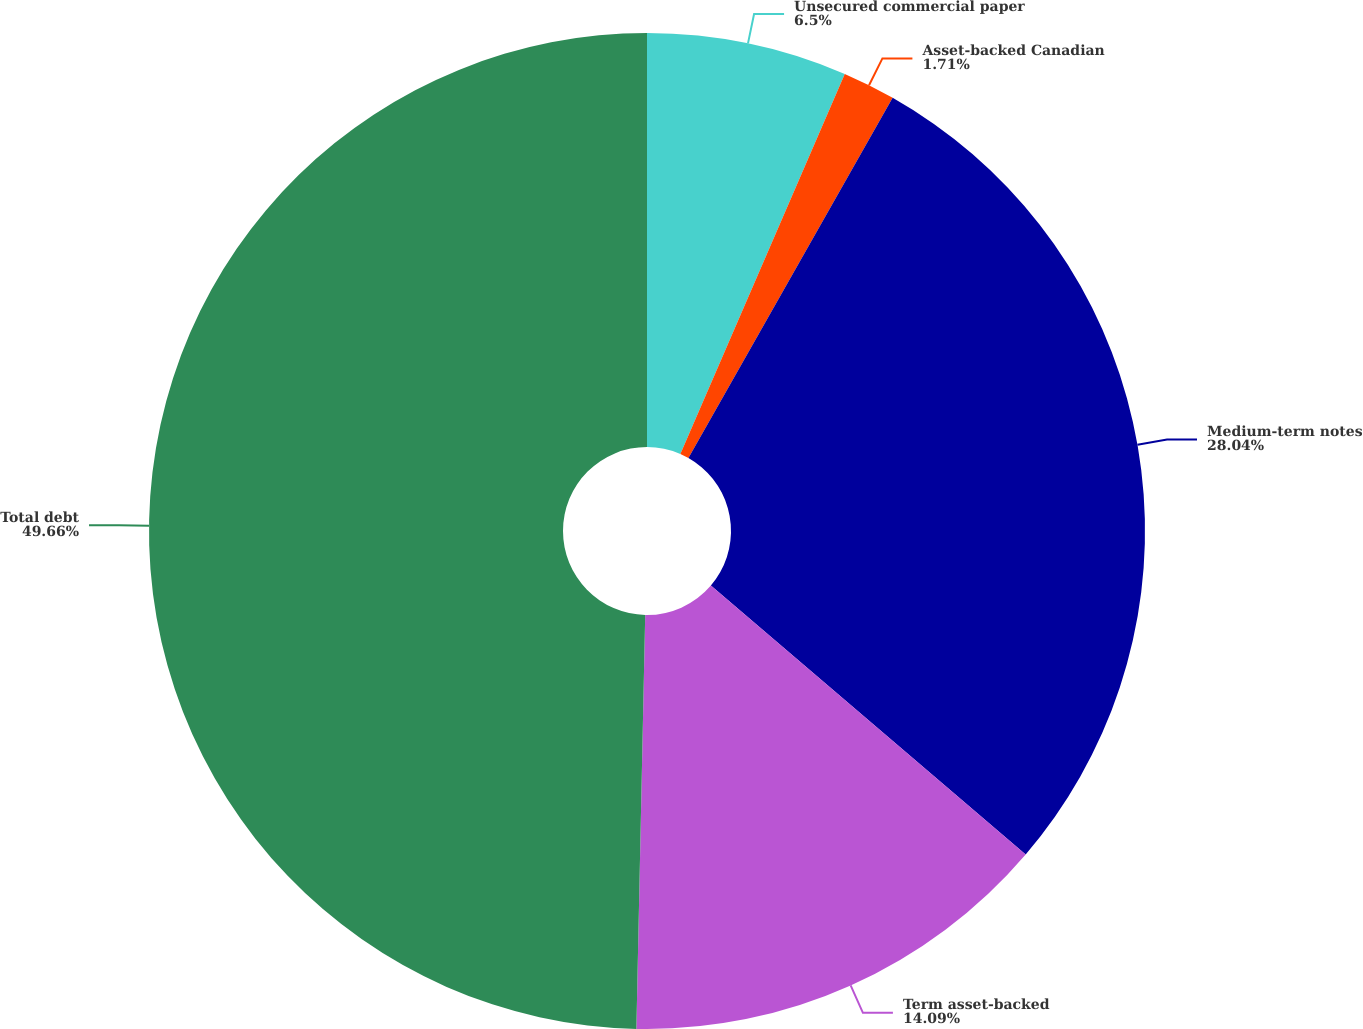Convert chart. <chart><loc_0><loc_0><loc_500><loc_500><pie_chart><fcel>Unsecured commercial paper<fcel>Asset-backed Canadian<fcel>Medium-term notes<fcel>Term asset-backed<fcel>Total debt<nl><fcel>6.5%<fcel>1.71%<fcel>28.04%<fcel>14.09%<fcel>49.66%<nl></chart> 